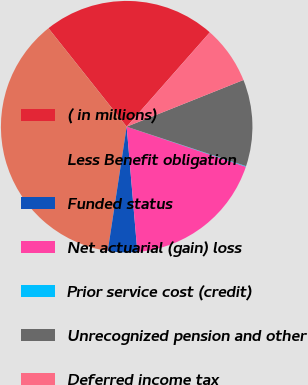<chart> <loc_0><loc_0><loc_500><loc_500><pie_chart><fcel>( in millions)<fcel>Less Benefit obligation<fcel>Funded status<fcel>Net actuarial (gain) loss<fcel>Prior service cost (credit)<fcel>Unrecognized pension and other<fcel>Deferred income tax<nl><fcel>22.18%<fcel>36.91%<fcel>3.76%<fcel>18.49%<fcel>0.08%<fcel>11.13%<fcel>7.45%<nl></chart> 